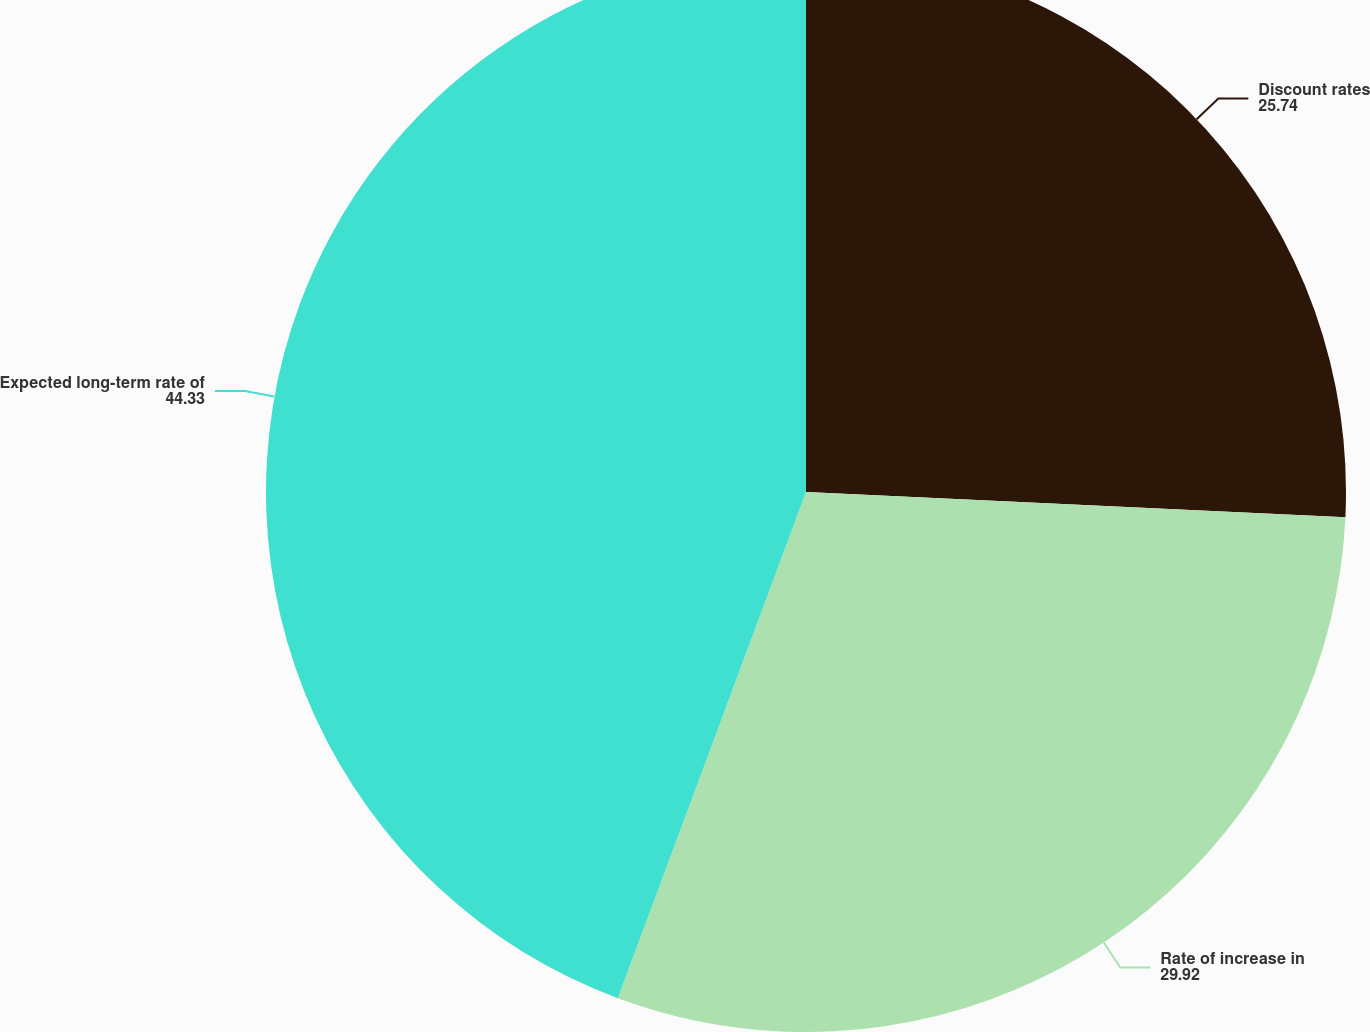Convert chart. <chart><loc_0><loc_0><loc_500><loc_500><pie_chart><fcel>Discount rates<fcel>Rate of increase in<fcel>Expected long-term rate of<nl><fcel>25.74%<fcel>29.92%<fcel>44.33%<nl></chart> 